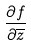<formula> <loc_0><loc_0><loc_500><loc_500>\frac { \partial f } { \partial \overline { z } }</formula> 